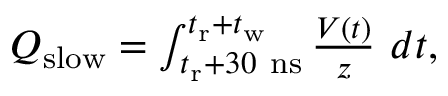Convert formula to latex. <formula><loc_0><loc_0><loc_500><loc_500>\begin{array} { r } { Q _ { s l o w } = \int _ { t _ { r } + 3 0 n s } ^ { t _ { r } + t _ { w } } \frac { V ( t ) } { z } d t , } \end{array}</formula> 